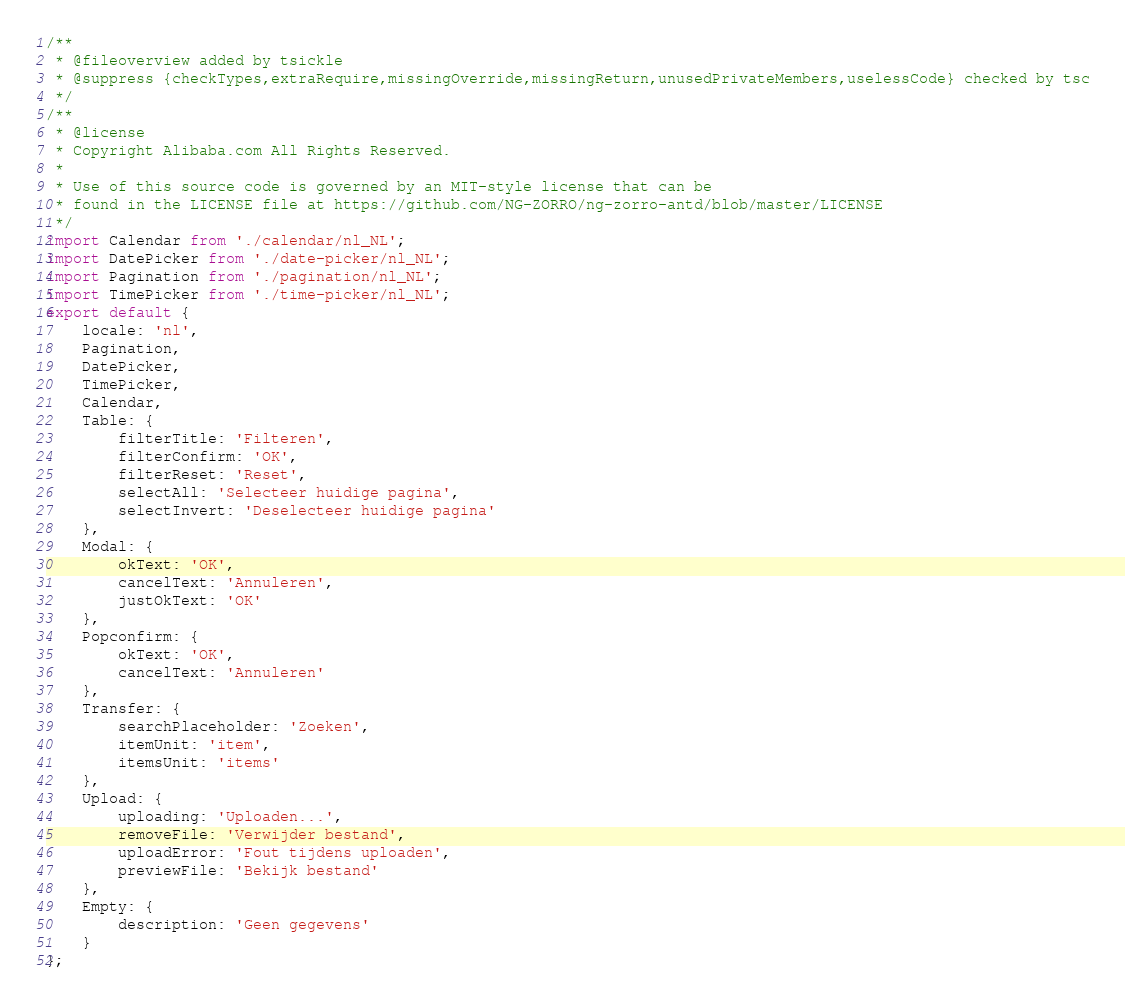Convert code to text. <code><loc_0><loc_0><loc_500><loc_500><_JavaScript_>/**
 * @fileoverview added by tsickle
 * @suppress {checkTypes,extraRequire,missingOverride,missingReturn,unusedPrivateMembers,uselessCode} checked by tsc
 */
/**
 * @license
 * Copyright Alibaba.com All Rights Reserved.
 *
 * Use of this source code is governed by an MIT-style license that can be
 * found in the LICENSE file at https://github.com/NG-ZORRO/ng-zorro-antd/blob/master/LICENSE
 */
import Calendar from './calendar/nl_NL';
import DatePicker from './date-picker/nl_NL';
import Pagination from './pagination/nl_NL';
import TimePicker from './time-picker/nl_NL';
export default {
    locale: 'nl',
    Pagination,
    DatePicker,
    TimePicker,
    Calendar,
    Table: {
        filterTitle: 'Filteren',
        filterConfirm: 'OK',
        filterReset: 'Reset',
        selectAll: 'Selecteer huidige pagina',
        selectInvert: 'Deselecteer huidige pagina'
    },
    Modal: {
        okText: 'OK',
        cancelText: 'Annuleren',
        justOkText: 'OK'
    },
    Popconfirm: {
        okText: 'OK',
        cancelText: 'Annuleren'
    },
    Transfer: {
        searchPlaceholder: 'Zoeken',
        itemUnit: 'item',
        itemsUnit: 'items'
    },
    Upload: {
        uploading: 'Uploaden...',
        removeFile: 'Verwijder bestand',
        uploadError: 'Fout tijdens uploaden',
        previewFile: 'Bekijk bestand'
    },
    Empty: {
        description: 'Geen gegevens'
    }
};</code> 